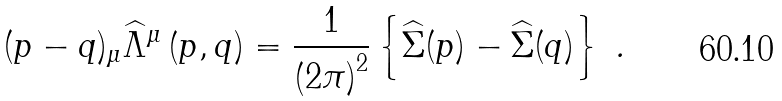Convert formula to latex. <formula><loc_0><loc_0><loc_500><loc_500>( p - q ) _ { \mu } \widehat { \Lambda } ^ { \mu } \left ( p , q \right ) = \frac { 1 } { \left ( 2 \pi \right ) ^ { 2 } } \left \{ \widehat { \Sigma } ( p ) - \widehat { \Sigma } ( q ) \right \} \text { .}</formula> 